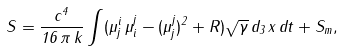<formula> <loc_0><loc_0><loc_500><loc_500>S = \frac { c ^ { 4 } } { 1 6 \, \pi \, k } \int ( \mu ^ { i } _ { j } \, \mu ^ { j } _ { i } - ( \mu ^ { j } _ { j } ) ^ { 2 } + R ) \sqrt { \gamma } \, d _ { 3 } \, x \, d t + S _ { m } ,</formula> 